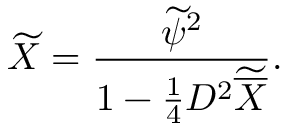<formula> <loc_0><loc_0><loc_500><loc_500>\widetilde { X } = { \frac { \widetilde { \psi } ^ { 2 } } { 1 - { \frac { 1 } { 4 } } D ^ { 2 } \widetilde { \overline { X } } } } .</formula> 